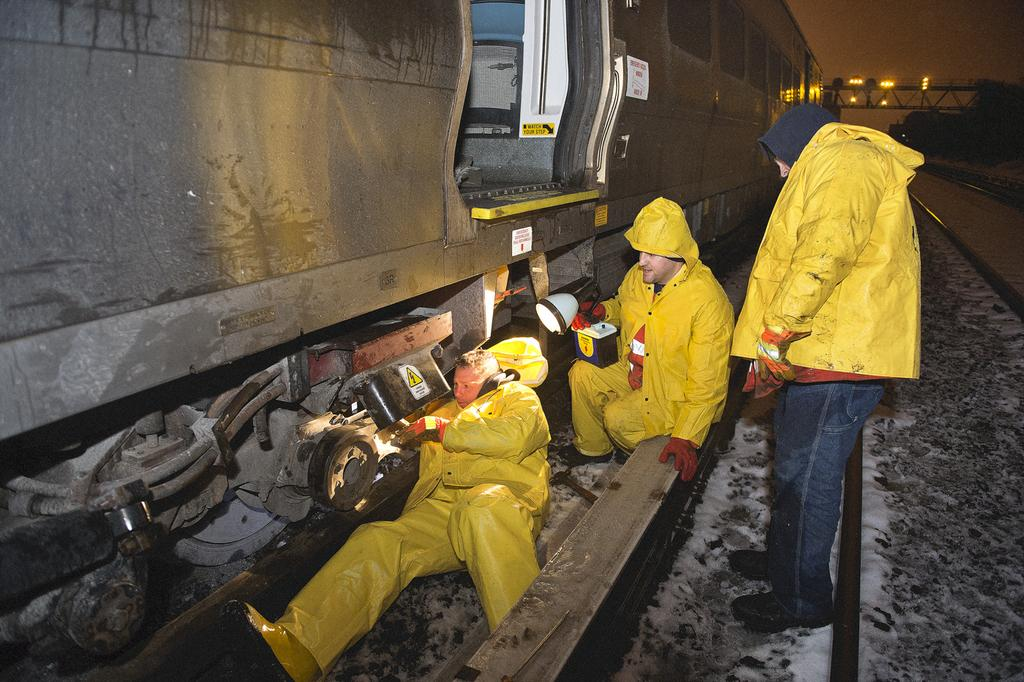How many people are in the image? There are three people in the image. What are the people doing in the image? One person is holding an object, but we cannot determine their exact actions from the provided facts. What can be seen on the tracks in the image? There is a train on the track in the image. What type of illumination is present in the image? There are lights visible in the image. What type of vegetation is present in the image? There are trees in the image. What type of structure is present in the image? There is a bridge in the image. What is visible in the background of the image? The sky is visible in the image. What type of box is being used to show respect to the bike in the image? There is no box or bike present in the image, so this question cannot be answered. 